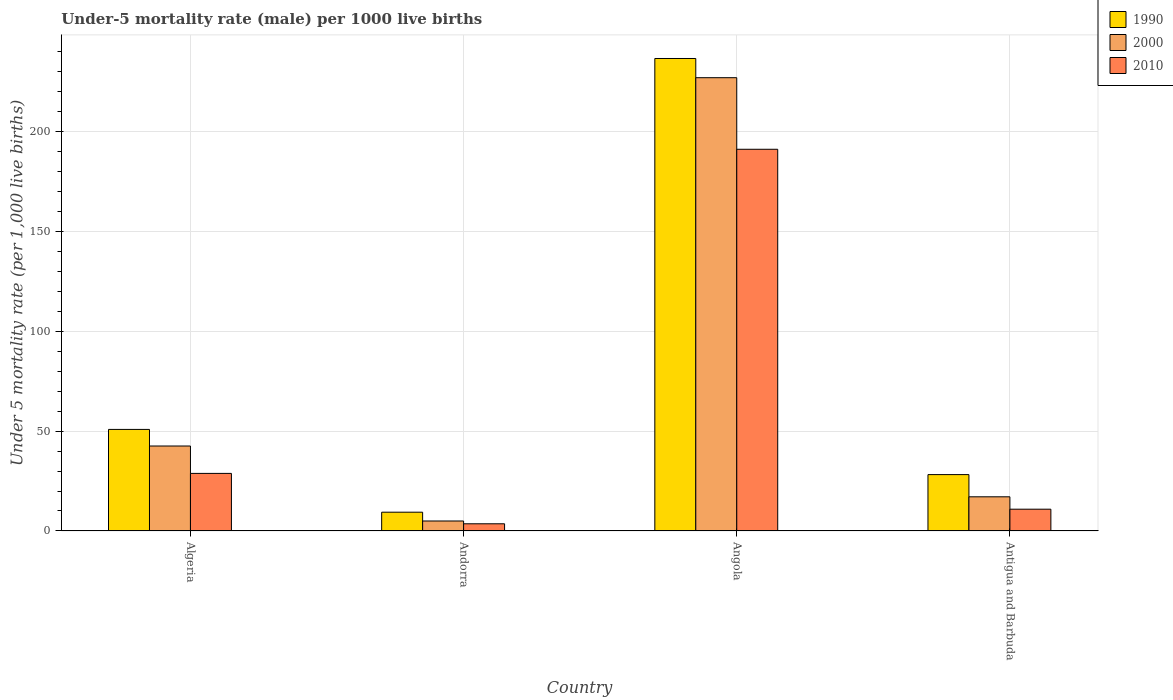Are the number of bars per tick equal to the number of legend labels?
Your response must be concise. Yes. Are the number of bars on each tick of the X-axis equal?
Ensure brevity in your answer.  Yes. How many bars are there on the 3rd tick from the left?
Your response must be concise. 3. How many bars are there on the 3rd tick from the right?
Provide a short and direct response. 3. What is the label of the 4th group of bars from the left?
Ensure brevity in your answer.  Antigua and Barbuda. In how many cases, is the number of bars for a given country not equal to the number of legend labels?
Offer a very short reply. 0. What is the under-five mortality rate in 1990 in Angola?
Make the answer very short. 236.3. Across all countries, what is the maximum under-five mortality rate in 2000?
Your answer should be compact. 226.7. In which country was the under-five mortality rate in 1990 maximum?
Give a very brief answer. Angola. In which country was the under-five mortality rate in 2000 minimum?
Provide a short and direct response. Andorra. What is the total under-five mortality rate in 1990 in the graph?
Your answer should be compact. 324.7. What is the difference between the under-five mortality rate in 2000 in Algeria and that in Andorra?
Your answer should be compact. 37.5. What is the average under-five mortality rate in 2000 per country?
Your response must be concise. 72.83. What is the difference between the under-five mortality rate of/in 2000 and under-five mortality rate of/in 1990 in Algeria?
Ensure brevity in your answer.  -8.3. What is the ratio of the under-five mortality rate in 1990 in Algeria to that in Angola?
Your response must be concise. 0.21. What is the difference between the highest and the second highest under-five mortality rate in 2010?
Give a very brief answer. -17.9. What is the difference between the highest and the lowest under-five mortality rate in 2010?
Your response must be concise. 187.3. What does the 3rd bar from the left in Andorra represents?
Your answer should be compact. 2010. What does the 1st bar from the right in Antigua and Barbuda represents?
Offer a terse response. 2010. Is it the case that in every country, the sum of the under-five mortality rate in 2010 and under-five mortality rate in 2000 is greater than the under-five mortality rate in 1990?
Offer a terse response. No. Are all the bars in the graph horizontal?
Provide a short and direct response. No. How many countries are there in the graph?
Give a very brief answer. 4. How many legend labels are there?
Offer a very short reply. 3. How are the legend labels stacked?
Offer a very short reply. Vertical. What is the title of the graph?
Your answer should be very brief. Under-5 mortality rate (male) per 1000 live births. Does "1962" appear as one of the legend labels in the graph?
Provide a short and direct response. No. What is the label or title of the X-axis?
Ensure brevity in your answer.  Country. What is the label or title of the Y-axis?
Offer a very short reply. Under 5 mortality rate (per 1,0 live births). What is the Under 5 mortality rate (per 1,000 live births) in 1990 in Algeria?
Offer a very short reply. 50.8. What is the Under 5 mortality rate (per 1,000 live births) of 2000 in Algeria?
Keep it short and to the point. 42.5. What is the Under 5 mortality rate (per 1,000 live births) in 2010 in Algeria?
Provide a succinct answer. 28.8. What is the Under 5 mortality rate (per 1,000 live births) of 1990 in Andorra?
Offer a very short reply. 9.4. What is the Under 5 mortality rate (per 1,000 live births) of 2010 in Andorra?
Give a very brief answer. 3.6. What is the Under 5 mortality rate (per 1,000 live births) of 1990 in Angola?
Offer a very short reply. 236.3. What is the Under 5 mortality rate (per 1,000 live births) in 2000 in Angola?
Your response must be concise. 226.7. What is the Under 5 mortality rate (per 1,000 live births) in 2010 in Angola?
Your answer should be compact. 190.9. What is the Under 5 mortality rate (per 1,000 live births) in 1990 in Antigua and Barbuda?
Give a very brief answer. 28.2. What is the Under 5 mortality rate (per 1,000 live births) of 2000 in Antigua and Barbuda?
Provide a succinct answer. 17.1. What is the Under 5 mortality rate (per 1,000 live births) of 2010 in Antigua and Barbuda?
Ensure brevity in your answer.  10.9. Across all countries, what is the maximum Under 5 mortality rate (per 1,000 live births) of 1990?
Your answer should be very brief. 236.3. Across all countries, what is the maximum Under 5 mortality rate (per 1,000 live births) in 2000?
Give a very brief answer. 226.7. Across all countries, what is the maximum Under 5 mortality rate (per 1,000 live births) in 2010?
Make the answer very short. 190.9. Across all countries, what is the minimum Under 5 mortality rate (per 1,000 live births) of 2000?
Ensure brevity in your answer.  5. Across all countries, what is the minimum Under 5 mortality rate (per 1,000 live births) in 2010?
Give a very brief answer. 3.6. What is the total Under 5 mortality rate (per 1,000 live births) of 1990 in the graph?
Your answer should be very brief. 324.7. What is the total Under 5 mortality rate (per 1,000 live births) of 2000 in the graph?
Your answer should be compact. 291.3. What is the total Under 5 mortality rate (per 1,000 live births) of 2010 in the graph?
Make the answer very short. 234.2. What is the difference between the Under 5 mortality rate (per 1,000 live births) of 1990 in Algeria and that in Andorra?
Your response must be concise. 41.4. What is the difference between the Under 5 mortality rate (per 1,000 live births) of 2000 in Algeria and that in Andorra?
Provide a short and direct response. 37.5. What is the difference between the Under 5 mortality rate (per 1,000 live births) in 2010 in Algeria and that in Andorra?
Give a very brief answer. 25.2. What is the difference between the Under 5 mortality rate (per 1,000 live births) of 1990 in Algeria and that in Angola?
Provide a short and direct response. -185.5. What is the difference between the Under 5 mortality rate (per 1,000 live births) in 2000 in Algeria and that in Angola?
Your response must be concise. -184.2. What is the difference between the Under 5 mortality rate (per 1,000 live births) of 2010 in Algeria and that in Angola?
Provide a short and direct response. -162.1. What is the difference between the Under 5 mortality rate (per 1,000 live births) in 1990 in Algeria and that in Antigua and Barbuda?
Make the answer very short. 22.6. What is the difference between the Under 5 mortality rate (per 1,000 live births) of 2000 in Algeria and that in Antigua and Barbuda?
Your answer should be very brief. 25.4. What is the difference between the Under 5 mortality rate (per 1,000 live births) in 2010 in Algeria and that in Antigua and Barbuda?
Offer a terse response. 17.9. What is the difference between the Under 5 mortality rate (per 1,000 live births) in 1990 in Andorra and that in Angola?
Your answer should be very brief. -226.9. What is the difference between the Under 5 mortality rate (per 1,000 live births) in 2000 in Andorra and that in Angola?
Your answer should be very brief. -221.7. What is the difference between the Under 5 mortality rate (per 1,000 live births) of 2010 in Andorra and that in Angola?
Provide a short and direct response. -187.3. What is the difference between the Under 5 mortality rate (per 1,000 live births) of 1990 in Andorra and that in Antigua and Barbuda?
Your response must be concise. -18.8. What is the difference between the Under 5 mortality rate (per 1,000 live births) in 2000 in Andorra and that in Antigua and Barbuda?
Your response must be concise. -12.1. What is the difference between the Under 5 mortality rate (per 1,000 live births) in 2010 in Andorra and that in Antigua and Barbuda?
Provide a succinct answer. -7.3. What is the difference between the Under 5 mortality rate (per 1,000 live births) of 1990 in Angola and that in Antigua and Barbuda?
Provide a succinct answer. 208.1. What is the difference between the Under 5 mortality rate (per 1,000 live births) in 2000 in Angola and that in Antigua and Barbuda?
Offer a terse response. 209.6. What is the difference between the Under 5 mortality rate (per 1,000 live births) of 2010 in Angola and that in Antigua and Barbuda?
Keep it short and to the point. 180. What is the difference between the Under 5 mortality rate (per 1,000 live births) of 1990 in Algeria and the Under 5 mortality rate (per 1,000 live births) of 2000 in Andorra?
Your response must be concise. 45.8. What is the difference between the Under 5 mortality rate (per 1,000 live births) in 1990 in Algeria and the Under 5 mortality rate (per 1,000 live births) in 2010 in Andorra?
Offer a very short reply. 47.2. What is the difference between the Under 5 mortality rate (per 1,000 live births) in 2000 in Algeria and the Under 5 mortality rate (per 1,000 live births) in 2010 in Andorra?
Your answer should be very brief. 38.9. What is the difference between the Under 5 mortality rate (per 1,000 live births) of 1990 in Algeria and the Under 5 mortality rate (per 1,000 live births) of 2000 in Angola?
Provide a short and direct response. -175.9. What is the difference between the Under 5 mortality rate (per 1,000 live births) of 1990 in Algeria and the Under 5 mortality rate (per 1,000 live births) of 2010 in Angola?
Provide a succinct answer. -140.1. What is the difference between the Under 5 mortality rate (per 1,000 live births) in 2000 in Algeria and the Under 5 mortality rate (per 1,000 live births) in 2010 in Angola?
Provide a succinct answer. -148.4. What is the difference between the Under 5 mortality rate (per 1,000 live births) of 1990 in Algeria and the Under 5 mortality rate (per 1,000 live births) of 2000 in Antigua and Barbuda?
Provide a short and direct response. 33.7. What is the difference between the Under 5 mortality rate (per 1,000 live births) in 1990 in Algeria and the Under 5 mortality rate (per 1,000 live births) in 2010 in Antigua and Barbuda?
Give a very brief answer. 39.9. What is the difference between the Under 5 mortality rate (per 1,000 live births) in 2000 in Algeria and the Under 5 mortality rate (per 1,000 live births) in 2010 in Antigua and Barbuda?
Provide a short and direct response. 31.6. What is the difference between the Under 5 mortality rate (per 1,000 live births) in 1990 in Andorra and the Under 5 mortality rate (per 1,000 live births) in 2000 in Angola?
Your answer should be compact. -217.3. What is the difference between the Under 5 mortality rate (per 1,000 live births) of 1990 in Andorra and the Under 5 mortality rate (per 1,000 live births) of 2010 in Angola?
Make the answer very short. -181.5. What is the difference between the Under 5 mortality rate (per 1,000 live births) of 2000 in Andorra and the Under 5 mortality rate (per 1,000 live births) of 2010 in Angola?
Provide a succinct answer. -185.9. What is the difference between the Under 5 mortality rate (per 1,000 live births) in 1990 in Andorra and the Under 5 mortality rate (per 1,000 live births) in 2010 in Antigua and Barbuda?
Offer a terse response. -1.5. What is the difference between the Under 5 mortality rate (per 1,000 live births) in 2000 in Andorra and the Under 5 mortality rate (per 1,000 live births) in 2010 in Antigua and Barbuda?
Your answer should be very brief. -5.9. What is the difference between the Under 5 mortality rate (per 1,000 live births) of 1990 in Angola and the Under 5 mortality rate (per 1,000 live births) of 2000 in Antigua and Barbuda?
Keep it short and to the point. 219.2. What is the difference between the Under 5 mortality rate (per 1,000 live births) in 1990 in Angola and the Under 5 mortality rate (per 1,000 live births) in 2010 in Antigua and Barbuda?
Your response must be concise. 225.4. What is the difference between the Under 5 mortality rate (per 1,000 live births) of 2000 in Angola and the Under 5 mortality rate (per 1,000 live births) of 2010 in Antigua and Barbuda?
Your answer should be very brief. 215.8. What is the average Under 5 mortality rate (per 1,000 live births) of 1990 per country?
Give a very brief answer. 81.17. What is the average Under 5 mortality rate (per 1,000 live births) of 2000 per country?
Make the answer very short. 72.83. What is the average Under 5 mortality rate (per 1,000 live births) of 2010 per country?
Make the answer very short. 58.55. What is the difference between the Under 5 mortality rate (per 1,000 live births) of 1990 and Under 5 mortality rate (per 1,000 live births) of 2010 in Algeria?
Provide a succinct answer. 22. What is the difference between the Under 5 mortality rate (per 1,000 live births) in 2000 and Under 5 mortality rate (per 1,000 live births) in 2010 in Algeria?
Your response must be concise. 13.7. What is the difference between the Under 5 mortality rate (per 1,000 live births) of 1990 and Under 5 mortality rate (per 1,000 live births) of 2010 in Andorra?
Provide a short and direct response. 5.8. What is the difference between the Under 5 mortality rate (per 1,000 live births) of 1990 and Under 5 mortality rate (per 1,000 live births) of 2010 in Angola?
Offer a terse response. 45.4. What is the difference between the Under 5 mortality rate (per 1,000 live births) of 2000 and Under 5 mortality rate (per 1,000 live births) of 2010 in Angola?
Keep it short and to the point. 35.8. What is the difference between the Under 5 mortality rate (per 1,000 live births) in 1990 and Under 5 mortality rate (per 1,000 live births) in 2000 in Antigua and Barbuda?
Keep it short and to the point. 11.1. What is the ratio of the Under 5 mortality rate (per 1,000 live births) of 1990 in Algeria to that in Andorra?
Your answer should be compact. 5.4. What is the ratio of the Under 5 mortality rate (per 1,000 live births) of 2000 in Algeria to that in Andorra?
Your response must be concise. 8.5. What is the ratio of the Under 5 mortality rate (per 1,000 live births) of 1990 in Algeria to that in Angola?
Ensure brevity in your answer.  0.21. What is the ratio of the Under 5 mortality rate (per 1,000 live births) of 2000 in Algeria to that in Angola?
Provide a succinct answer. 0.19. What is the ratio of the Under 5 mortality rate (per 1,000 live births) of 2010 in Algeria to that in Angola?
Give a very brief answer. 0.15. What is the ratio of the Under 5 mortality rate (per 1,000 live births) of 1990 in Algeria to that in Antigua and Barbuda?
Keep it short and to the point. 1.8. What is the ratio of the Under 5 mortality rate (per 1,000 live births) of 2000 in Algeria to that in Antigua and Barbuda?
Your response must be concise. 2.49. What is the ratio of the Under 5 mortality rate (per 1,000 live births) in 2010 in Algeria to that in Antigua and Barbuda?
Offer a terse response. 2.64. What is the ratio of the Under 5 mortality rate (per 1,000 live births) of 1990 in Andorra to that in Angola?
Make the answer very short. 0.04. What is the ratio of the Under 5 mortality rate (per 1,000 live births) of 2000 in Andorra to that in Angola?
Provide a short and direct response. 0.02. What is the ratio of the Under 5 mortality rate (per 1,000 live births) of 2010 in Andorra to that in Angola?
Provide a succinct answer. 0.02. What is the ratio of the Under 5 mortality rate (per 1,000 live births) in 2000 in Andorra to that in Antigua and Barbuda?
Give a very brief answer. 0.29. What is the ratio of the Under 5 mortality rate (per 1,000 live births) of 2010 in Andorra to that in Antigua and Barbuda?
Provide a short and direct response. 0.33. What is the ratio of the Under 5 mortality rate (per 1,000 live births) in 1990 in Angola to that in Antigua and Barbuda?
Ensure brevity in your answer.  8.38. What is the ratio of the Under 5 mortality rate (per 1,000 live births) of 2000 in Angola to that in Antigua and Barbuda?
Make the answer very short. 13.26. What is the ratio of the Under 5 mortality rate (per 1,000 live births) of 2010 in Angola to that in Antigua and Barbuda?
Offer a terse response. 17.51. What is the difference between the highest and the second highest Under 5 mortality rate (per 1,000 live births) of 1990?
Provide a succinct answer. 185.5. What is the difference between the highest and the second highest Under 5 mortality rate (per 1,000 live births) of 2000?
Provide a succinct answer. 184.2. What is the difference between the highest and the second highest Under 5 mortality rate (per 1,000 live births) of 2010?
Your response must be concise. 162.1. What is the difference between the highest and the lowest Under 5 mortality rate (per 1,000 live births) of 1990?
Provide a succinct answer. 226.9. What is the difference between the highest and the lowest Under 5 mortality rate (per 1,000 live births) in 2000?
Offer a very short reply. 221.7. What is the difference between the highest and the lowest Under 5 mortality rate (per 1,000 live births) of 2010?
Offer a very short reply. 187.3. 